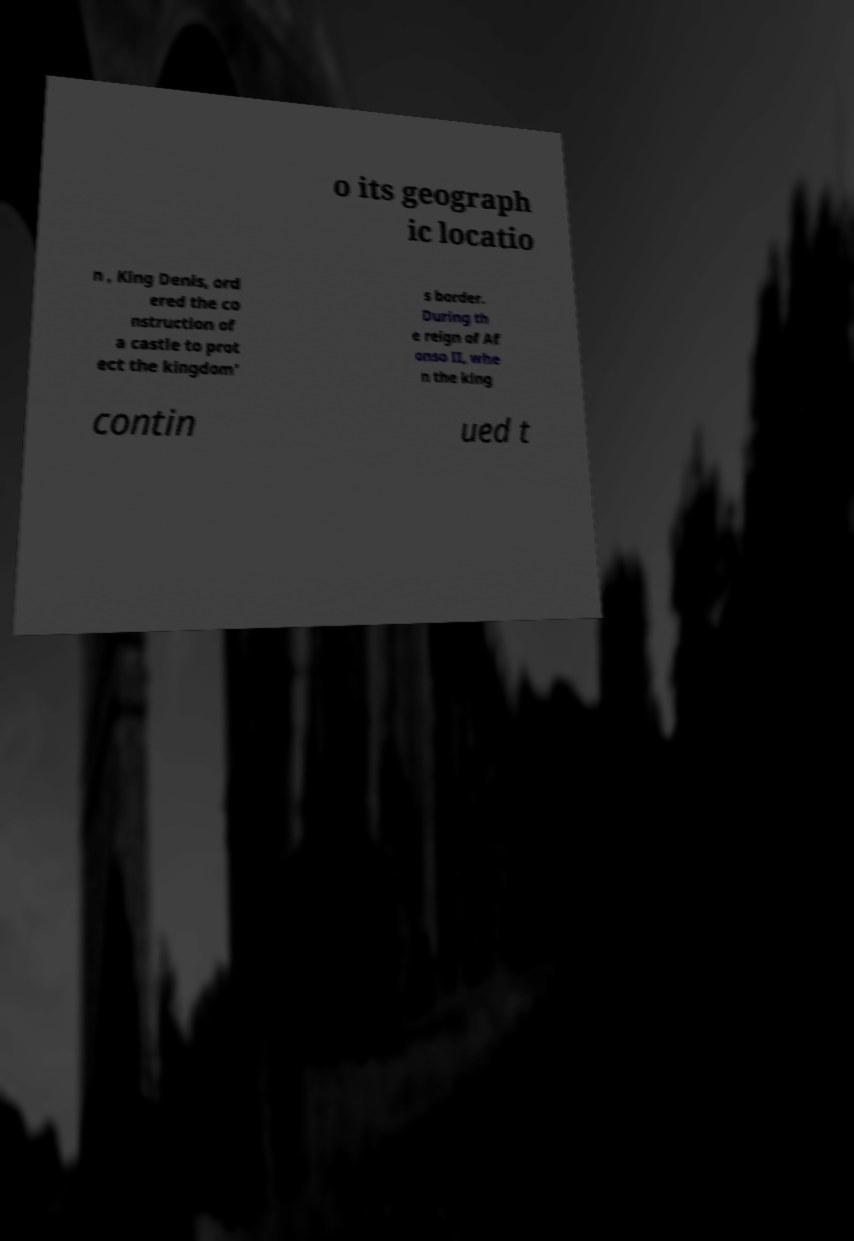Please identify and transcribe the text found in this image. o its geograph ic locatio n , King Denis, ord ered the co nstruction of a castle to prot ect the kingdom' s border. During th e reign of Af onso II, whe n the king contin ued t 